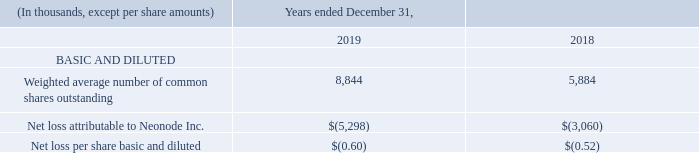14. Net Loss Per Share
Basic net loss per common share for the years ended December 31, 2019 and 2018 was computed by dividing the net loss attributable to Neonode Inc. for the relevant period by the weighted average number of shares of common stock outstanding during the year. Diluted loss per common share is computed by dividing net loss attributable to Neonode Inc. for the relevant period by the weighted average number of shares of common stock and common stock equivalents outstanding during the year.
Potential common stock equivalents of approximately 0 and 350,000 outstanding stock warrants, 0 and 11,000 shares issuable upon conversion of preferred stock and 0 and 0 stock options are excluded from the diluted earnings per share calculation for the years ended December 31, 2019 and 2018, respectively, due to their anti-dilutive effect.
How did the company compute the basic net loss per common share for 2018 and 2019? By dividing the net loss attributable to neonode inc. for the relevant period by the weighted average number of shares of common stock outstanding during the year. How do we compute diluted loss per common share? By dividing net loss attributable to neonode inc. for the relevant period by the weighted average number of shares of common stock and common stock equivalents outstanding during the year. What was the net loss attributable to Neonode Inc. in 2018 and 2019?
Answer scale should be: thousand. $(5,298), $(3,060). What is the percentage change in the weighted average number of common shares outstanding from 2018 to 2019?
Answer scale should be: percent. (8,844 - 5,884)/5,884 
Answer: 50.31. Which year has the highest net loss per share basic and diluted? -0.60<-0.52
Answer: 2019. What is the ratio of net loss attributable to Neonode Inc. in 2018 compared to 2019? 3,060/5,298 
Answer: 0.58. 